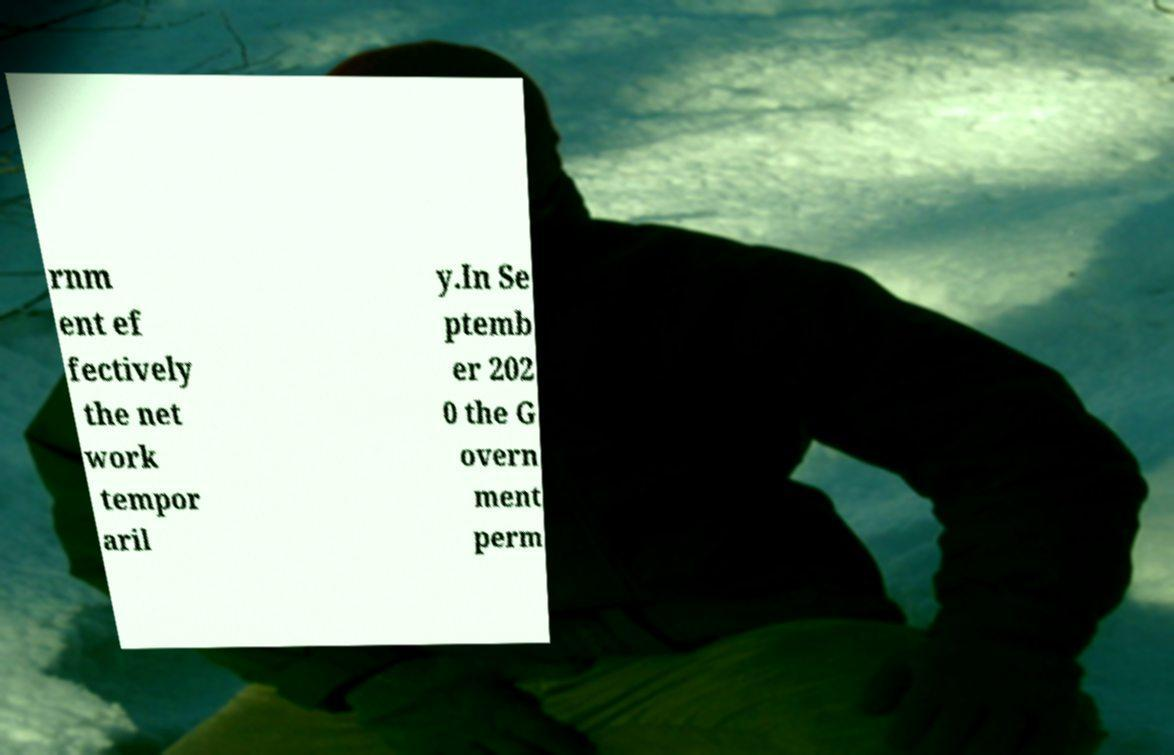Please identify and transcribe the text found in this image. rnm ent ef fectively the net work tempor aril y.In Se ptemb er 202 0 the G overn ment perm 